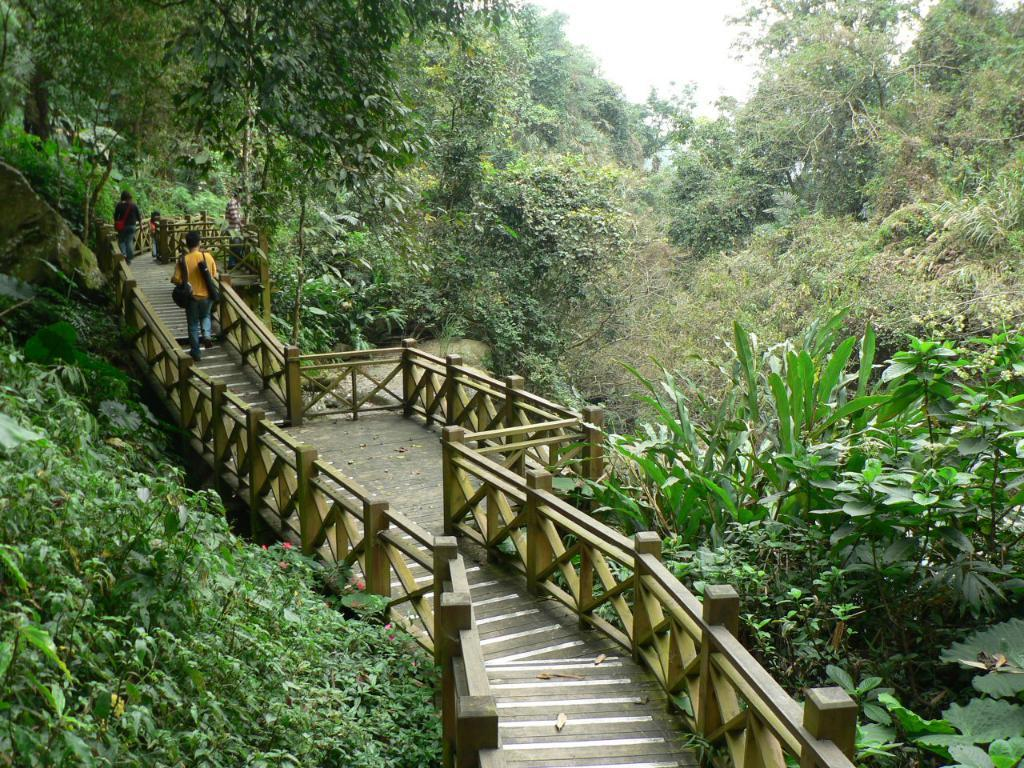What type of vegetation can be seen in the image? There are trees and flowers in the image. What structure is present in the image? There is a bridge in the image. What are the people in the image doing? People are walking on the bridge. What is visible at the top of the image? The sky is visible at the top of the image. What type of pickle is hanging from the trees in the image? There are no pickles present in the image; it features trees and flowers. What scene is depicted on the bridge in the image? There is no scene depicted on the bridge; people are simply walking on it. 